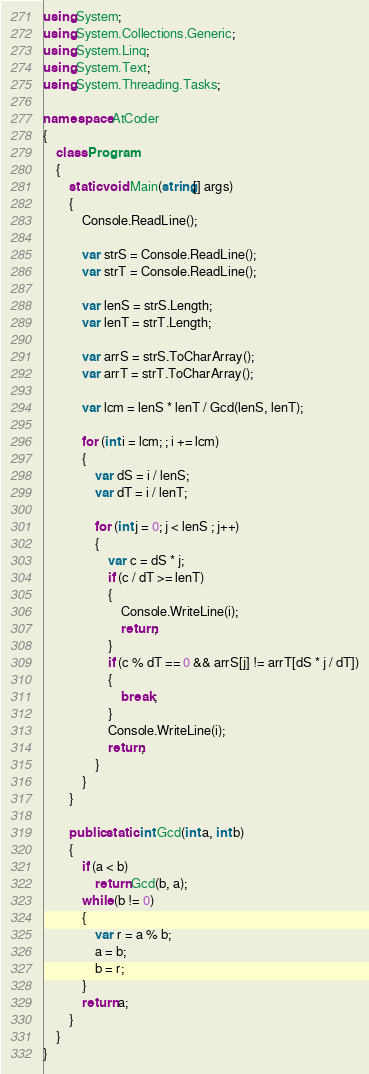Convert code to text. <code><loc_0><loc_0><loc_500><loc_500><_C#_>using System;
using System.Collections.Generic;
using System.Linq;
using System.Text;
using System.Threading.Tasks;

namespace AtCoder
{
    class Program
    {
        static void Main(string[] args)
        {
            Console.ReadLine();

            var strS = Console.ReadLine();
            var strT = Console.ReadLine();

            var lenS = strS.Length;
            var lenT = strT.Length;

            var arrS = strS.ToCharArray();
            var arrT = strT.ToCharArray();

            var lcm = lenS * lenT / Gcd(lenS, lenT);

            for (int i = lcm; ; i += lcm)
            {
                var dS = i / lenS;
                var dT = i / lenT;

                for (int j = 0; j < lenS ; j++)
                {
                    var c = dS * j;
                    if (c / dT >= lenT)
                    {
                        Console.WriteLine(i);
                        return;
                    }
                    if (c % dT == 0 && arrS[j] != arrT[dS * j / dT])
                    {
                        break;
                    }
                    Console.WriteLine(i);
                    return;
                }
            }
        }

        public static int Gcd(int a, int b)
        {
            if (a < b)
                return Gcd(b, a);
            while (b != 0)
            {
                var r = a % b;
                a = b;
                b = r;
            }
            return a;
        }
    }
}
</code> 